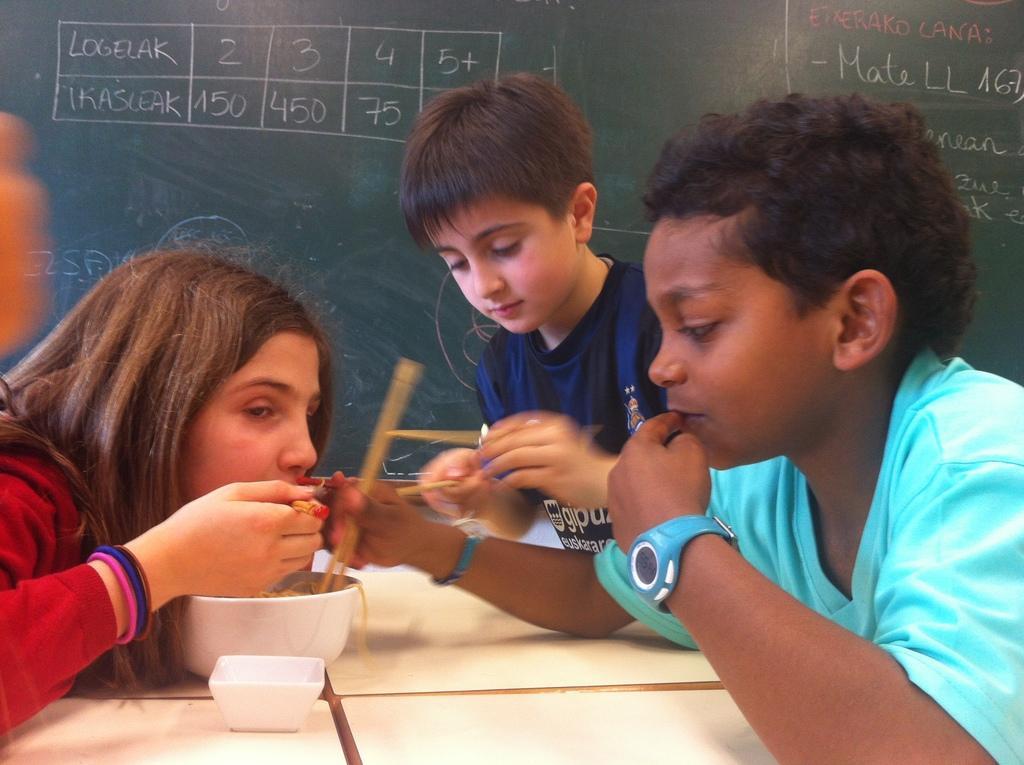In one or two sentences, can you explain what this image depicts? In this image in the front there is a table, on the table there are papers and there is a bowl and there is food inside the bowl and there are kids on the right side holding sticks in their hands and on the left side there is a girl eating food from the bowl in the background there is a board, on the board there are some text and numbers written on it. 